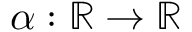<formula> <loc_0><loc_0><loc_500><loc_500>\alpha \colon \mathbb { R } \rightarrow \mathbb { R }</formula> 